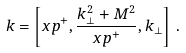Convert formula to latex. <formula><loc_0><loc_0><loc_500><loc_500>k = \left [ x p ^ { + } , \frac { { k } ^ { 2 } _ { \perp } + M ^ { 2 } } { x p ^ { + } } , { k } _ { \perp } \right ] \, .</formula> 